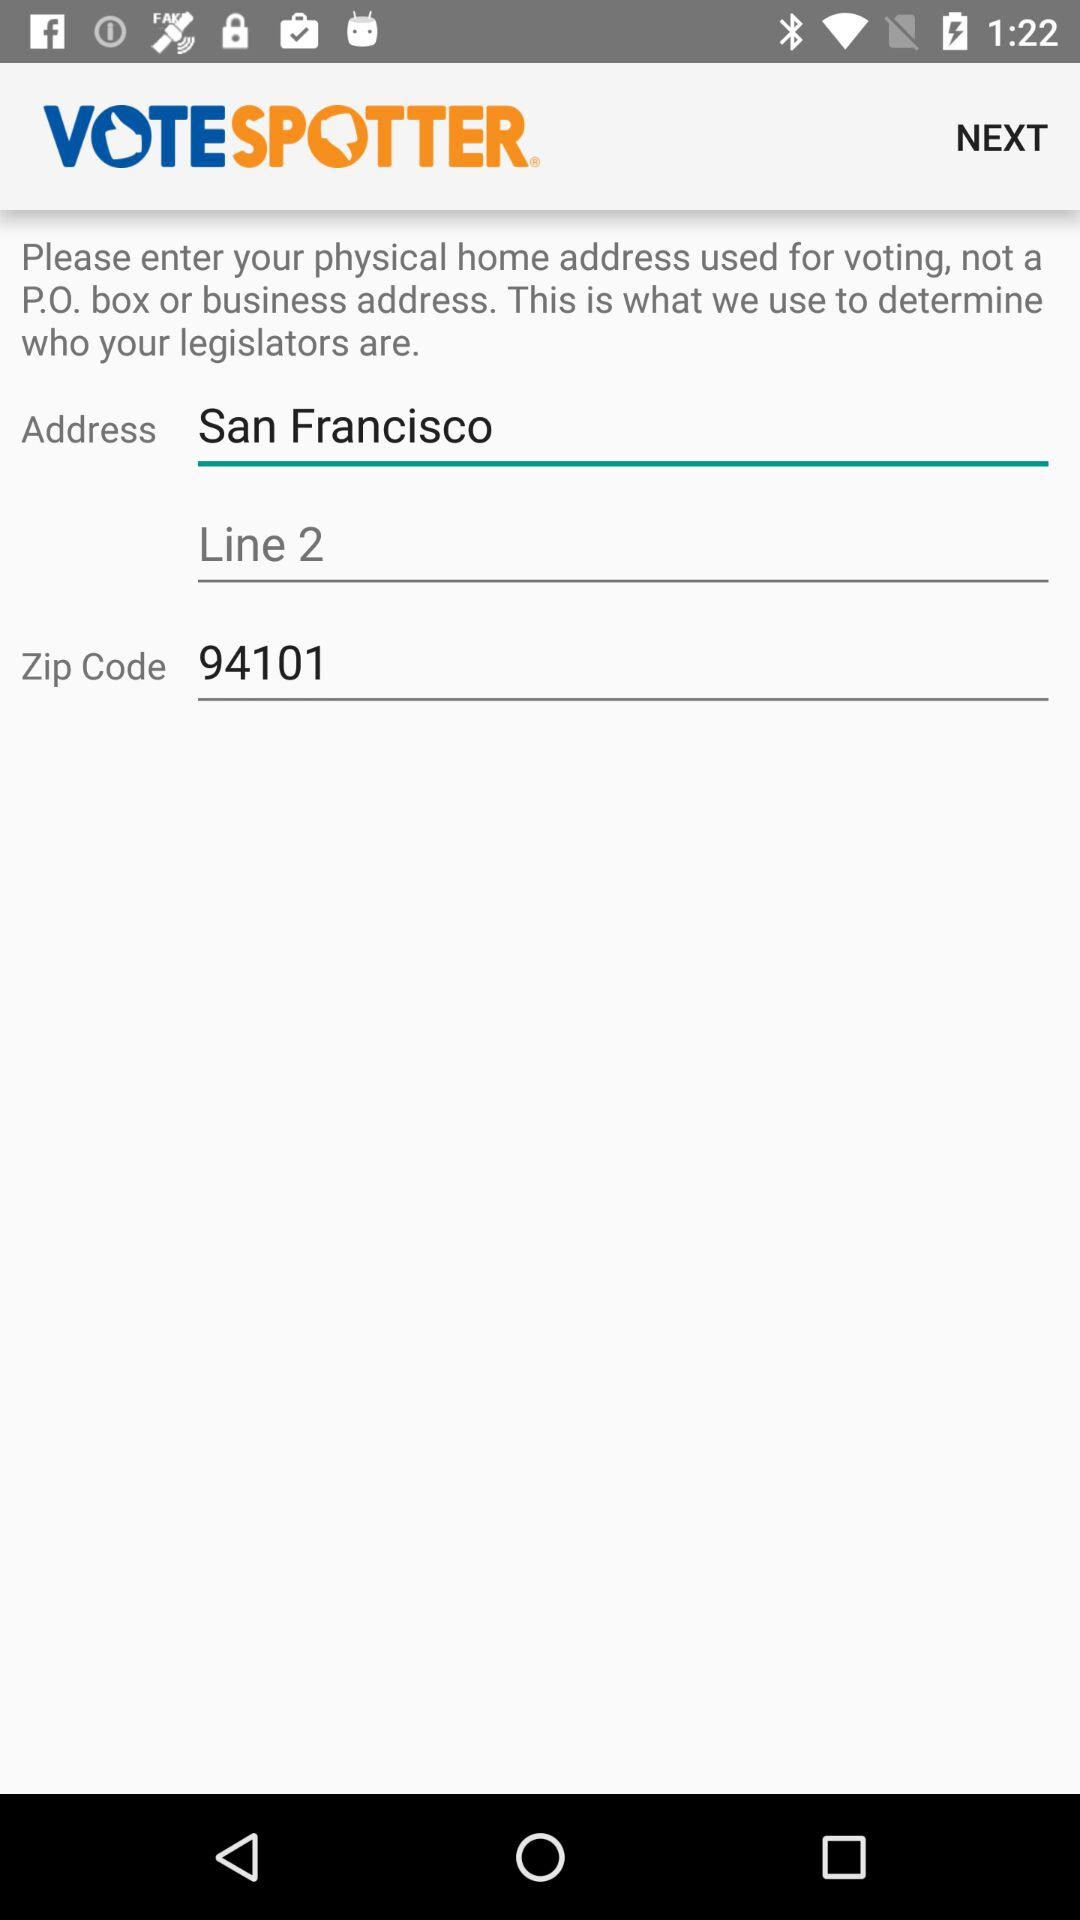What is the city? The city is San Francisco. 